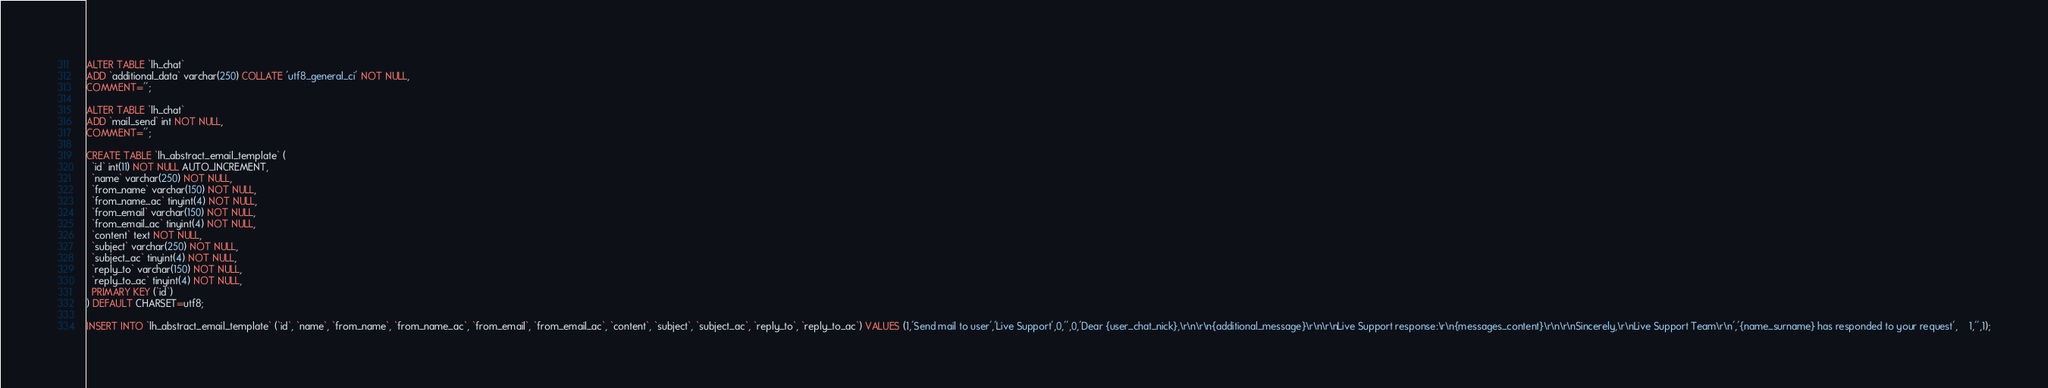<code> <loc_0><loc_0><loc_500><loc_500><_SQL_>ALTER TABLE `lh_chat`
ADD `additional_data` varchar(250) COLLATE 'utf8_general_ci' NOT NULL,
COMMENT='';

ALTER TABLE `lh_chat`
ADD `mail_send` int NOT NULL,
COMMENT='';

CREATE TABLE `lh_abstract_email_template` (
  `id` int(11) NOT NULL AUTO_INCREMENT,
  `name` varchar(250) NOT NULL,
  `from_name` varchar(150) NOT NULL,
  `from_name_ac` tinyint(4) NOT NULL,
  `from_email` varchar(150) NOT NULL,
  `from_email_ac` tinyint(4) NOT NULL,
  `content` text NOT NULL,
  `subject` varchar(250) NOT NULL,
  `subject_ac` tinyint(4) NOT NULL,
  `reply_to` varchar(150) NOT NULL,
  `reply_to_ac` tinyint(4) NOT NULL,
  PRIMARY KEY (`id`)
) DEFAULT CHARSET=utf8;

INSERT INTO `lh_abstract_email_template` (`id`, `name`, `from_name`, `from_name_ac`, `from_email`, `from_email_ac`, `content`, `subject`, `subject_ac`, `reply_to`, `reply_to_ac`) VALUES (1,'Send mail to user','Live Support',0,'',0,'Dear {user_chat_nick},\r\n\r\n{additional_message}\r\n\r\nLive Support response:\r\n{messages_content}\r\n\r\nSincerely,\r\nLive Support Team\r\n','{name_surname} has responded to your request',	1,'',1);
</code> 